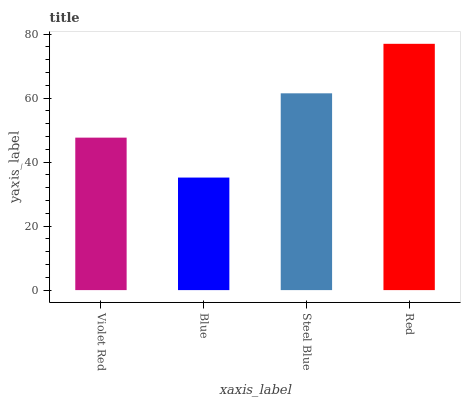Is Blue the minimum?
Answer yes or no. Yes. Is Red the maximum?
Answer yes or no. Yes. Is Steel Blue the minimum?
Answer yes or no. No. Is Steel Blue the maximum?
Answer yes or no. No. Is Steel Blue greater than Blue?
Answer yes or no. Yes. Is Blue less than Steel Blue?
Answer yes or no. Yes. Is Blue greater than Steel Blue?
Answer yes or no. No. Is Steel Blue less than Blue?
Answer yes or no. No. Is Steel Blue the high median?
Answer yes or no. Yes. Is Violet Red the low median?
Answer yes or no. Yes. Is Red the high median?
Answer yes or no. No. Is Red the low median?
Answer yes or no. No. 